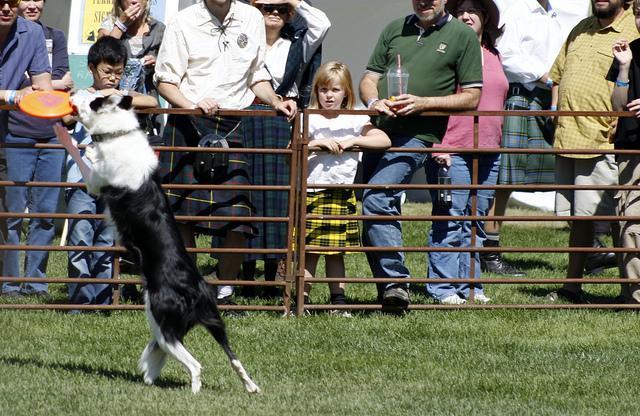How many people can be seen?
Give a very brief answer. 11. 